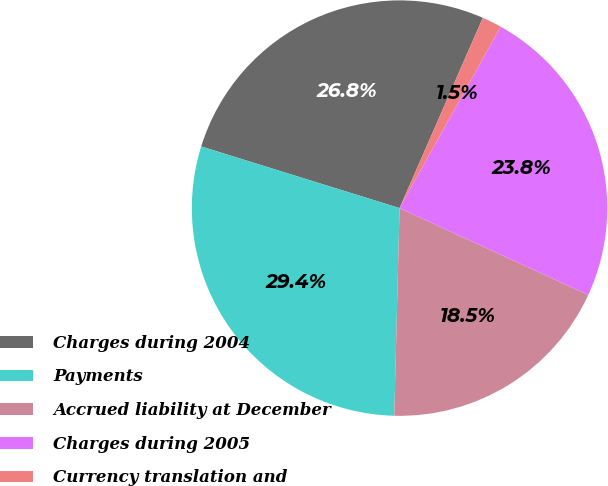<chart> <loc_0><loc_0><loc_500><loc_500><pie_chart><fcel>Charges during 2004<fcel>Payments<fcel>Accrued liability at December<fcel>Charges during 2005<fcel>Currency translation and<nl><fcel>26.77%<fcel>29.39%<fcel>18.54%<fcel>23.77%<fcel>1.53%<nl></chart> 